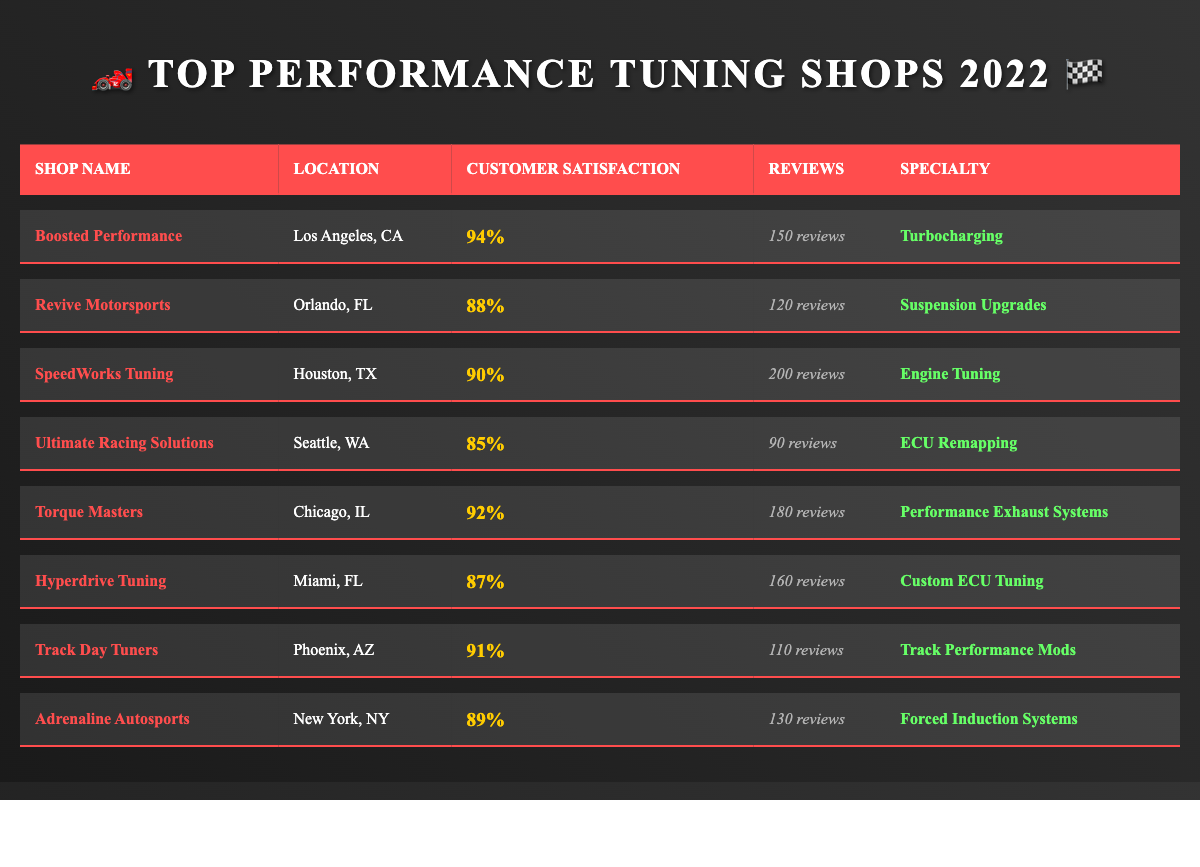What is the customer satisfaction rating for Boosted Performance? The table lists Boosted Performance's customer satisfaction rating as 94%.
Answer: 94% Which shop has the highest customer satisfaction rating? By comparing the ratings in the table, Boosted Performance has the highest rating of 94%.
Answer: Boosted Performance How many reviews did SpeedWorks Tuning receive? According to the table, SpeedWorks Tuning has a total of 200 reviews.
Answer: 200 reviews What specialty does Torque Masters focus on? The table states that Torque Masters specializes in "Performance Exhaust Systems."
Answer: Performance Exhaust Systems What is the average customer satisfaction rating of all shops listed? To find the average, sum the ratings: 94 + 88 + 90 + 85 + 92 + 87 + 91 + 89 = 716. There are 8 shops, so the average is 716/8 = 89.5.
Answer: 89.5 How many more reviews does Hyperdrive Tuning have compared to Revive Motorsports? Hyperdrive Tuning has 160 reviews and Revive Motorsports has 120 reviews. The difference is 160 - 120 = 40.
Answer: 40 reviews Is there a shop located in Miami, FL? Yes, Hyperdrive Tuning is located in Miami, FL, as listed in the table.
Answer: Yes Which shop has a customer satisfaction rating of 85%? The table shows that Ultimate Racing Solutions has a customer satisfaction rating of 85%.
Answer: Ultimate Racing Solutions What is the total number of reviews for all the shops combined? To find the total, sum the reviews: 150 + 120 + 200 + 90 + 180 + 160 + 110 + 130 = 1,140 reviews.
Answer: 1,140 reviews Which tuning shop is located in New York, NY? The table indicates that Adrenaline Autosports is located in New York, NY.
Answer: Adrenaline Autosports If we consider only shops with ratings above 90%, how many of them are there? The shops with ratings above 90% are Boosted Performance (94%), Torque Masters (92%), and Track Day Tuners (91%). That gives a total of 3 shops.
Answer: 3 shops 